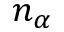Convert formula to latex. <formula><loc_0><loc_0><loc_500><loc_500>n _ { \alpha }</formula> 